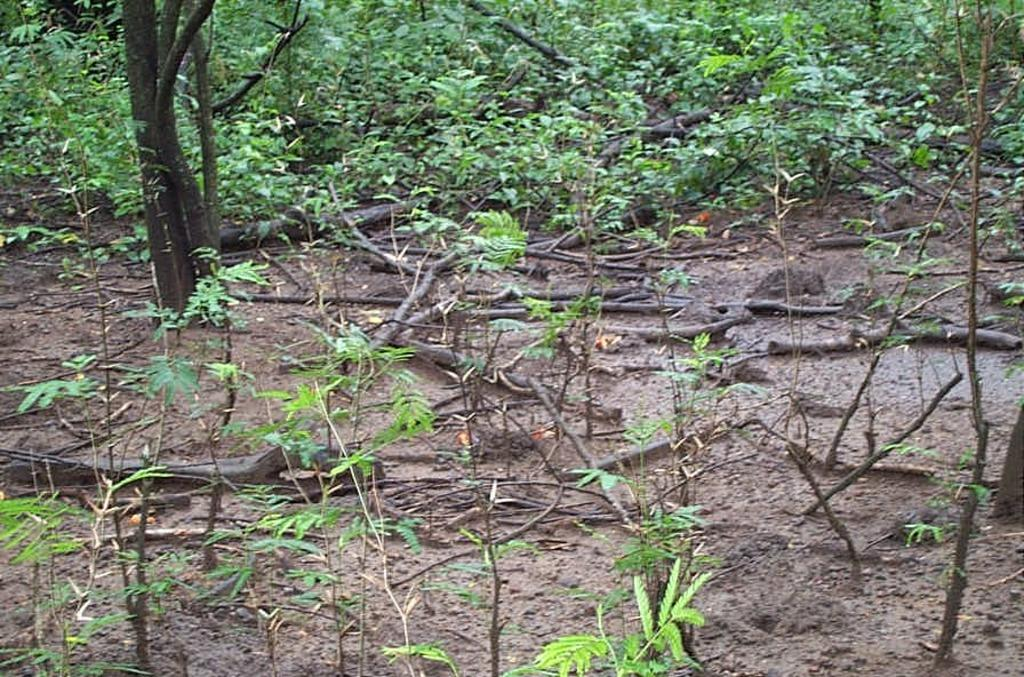What type of vegetation is present in the image? There is grass and trees in the image. Can you describe the natural environment depicted in the image? The image features grass and trees, which suggests a natural setting. How much money is being exchanged during the feast in the image? There is no feast or exchange of money present in the image; it features grass and trees. 